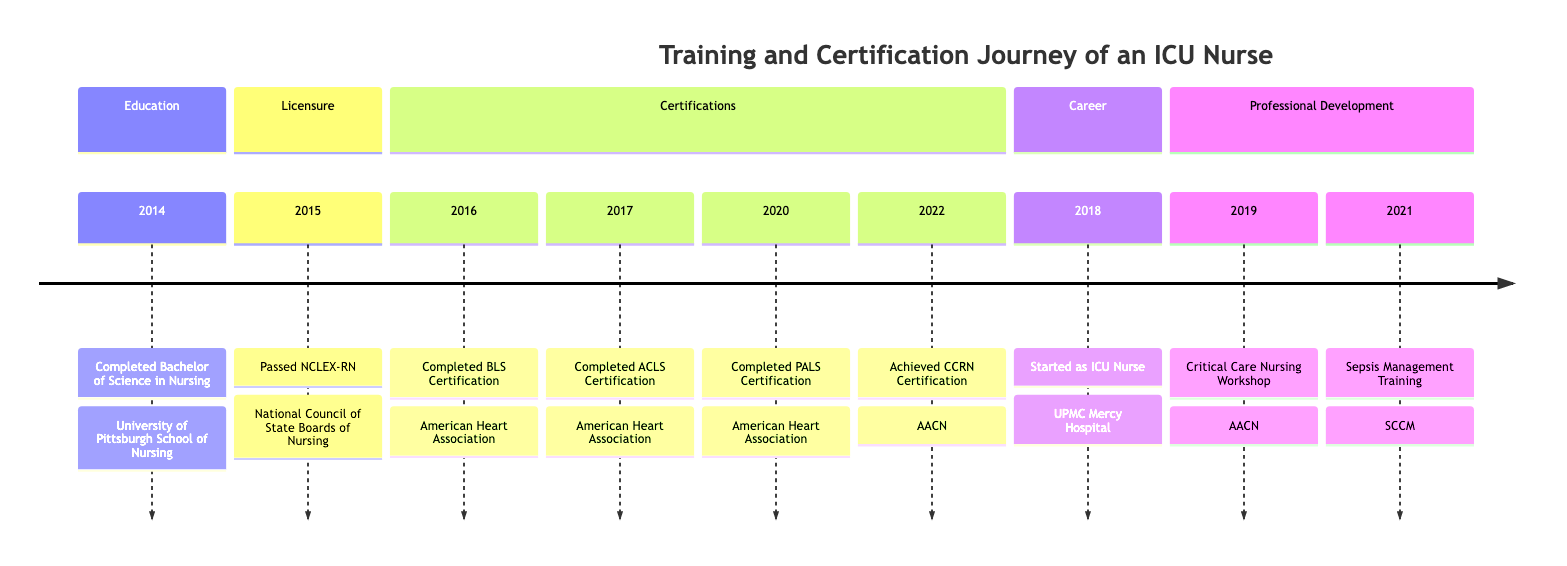What year did the nurse complete their Bachelor of Science in Nursing? The diagram shows that the milestone for completing the Bachelor of Science in Nursing occurred in 2014. This is the first event listed under the Education section.
Answer: 2014 What certification was achieved in 2022? According to the timeline, the nurse achieved the Critical Care Registered Nurse (CCRN) Certification in the year 2022, listed in the Certifications section.
Answer: CCRN Certification How many certifications are listed in the timeline? By counting the events in the Certifications section of the timeline, we see four milestones: BLS, ACLS, PALS, and CCRN certifications, leading to a total of four certifications.
Answer: 4 Which workshop did the nurse attend in 2019? The timeline indicates that the nurse attended a Critical Care Nursing Workshop in the year 2019, which is categorized under the Professional Development section.
Answer: Critical Care Nursing Workshop What institution provided the BLS Certification? The diagram specifies that the Basic Life Support (BLS) Certification was completed through the American Heart Association. This information is linked to the corresponding milestone under the Certifications section.
Answer: American Heart Association When did the nurse start working as an ICU Nurse? By examining the Career section of the timeline, it states that the nurse started working as an ICU Nurse in 2018, marking a significant transition in their professional journey.
Answer: 2018 How many years passed between completing the NCLEX-RN and starting the ICU nursing job? The nurse passed the NCLEX-RN in 2015 and began working as an ICU Nurse in 2018. The difference is three years, calculated by subtracting 2015 from 2018.
Answer: 3 What is the sequence of certifications completed from 2016 to 2022? The certifications completed in order are: BLS (2016), ACLS (2017), PALS (2020), and CCRN (2022). This offers a chronological sequence of the certifications obtained over the years.
Answer: BLS, ACLS, PALS, CCRN In which year was the Sepsis Management and Protocol Training attended? The timeline indicates that the Sepsis Management and Protocol Training was attended in 2021, as specified in the Professional Development section of the diagram.
Answer: 2021 